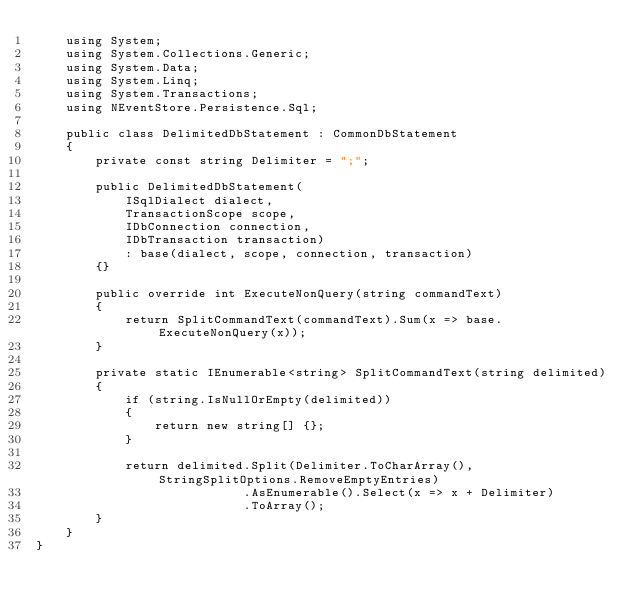Convert code to text. <code><loc_0><loc_0><loc_500><loc_500><_C#_>    using System;
    using System.Collections.Generic;
    using System.Data;
    using System.Linq;
    using System.Transactions;
    using NEventStore.Persistence.Sql;

    public class DelimitedDbStatement : CommonDbStatement
    {
        private const string Delimiter = ";";

        public DelimitedDbStatement(
            ISqlDialect dialect,
            TransactionScope scope,
            IDbConnection connection,
            IDbTransaction transaction)
            : base(dialect, scope, connection, transaction)
        {}

        public override int ExecuteNonQuery(string commandText)
        {
            return SplitCommandText(commandText).Sum(x => base.ExecuteNonQuery(x));
        }

        private static IEnumerable<string> SplitCommandText(string delimited)
        {
            if (string.IsNullOrEmpty(delimited))
            {
                return new string[] {};
            }

            return delimited.Split(Delimiter.ToCharArray(), StringSplitOptions.RemoveEmptyEntries)
                            .AsEnumerable().Select(x => x + Delimiter)
                            .ToArray();
        }
    }
}</code> 